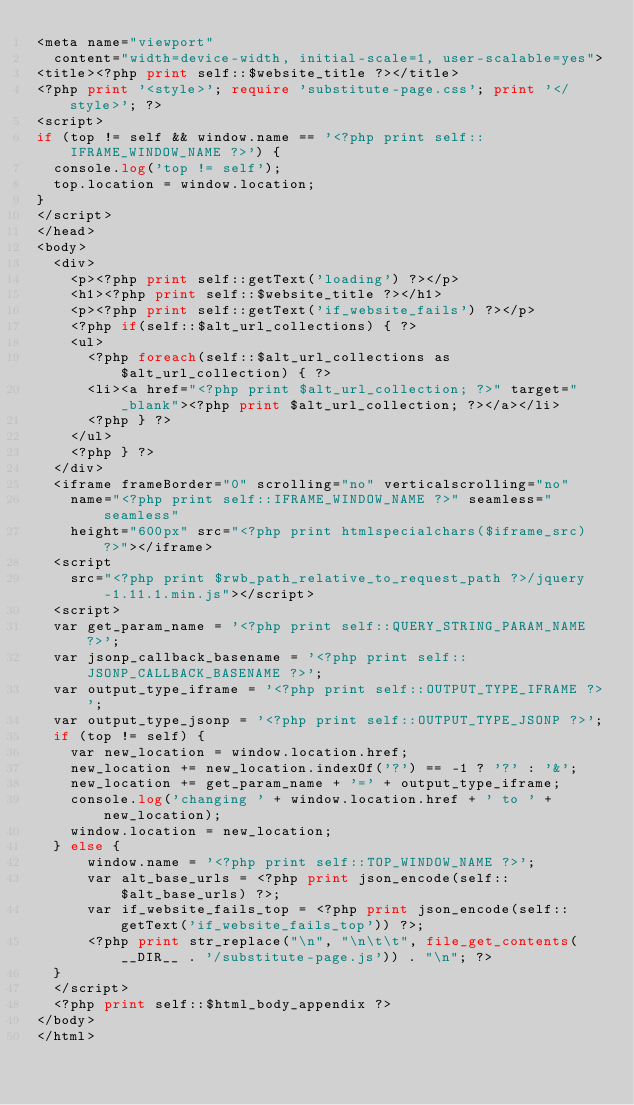<code> <loc_0><loc_0><loc_500><loc_500><_PHP_><meta name="viewport"
	content="width=device-width, initial-scale=1, user-scalable=yes">
<title><?php print self::$website_title ?></title>
<?php print '<style>'; require 'substitute-page.css'; print '</style>'; ?>
<script>
if (top != self && window.name == '<?php print self::IFRAME_WINDOW_NAME ?>') {
	console.log('top != self');
	top.location = window.location;
}
</script>
</head>
<body>
	<div>
		<p><?php print self::getText('loading') ?></p>
		<h1><?php print self::$website_title ?></h1>
		<p><?php print self::getText('if_website_fails') ?></p>
		<?php if(self::$alt_url_collections) { ?>
		<ul>
			<?php foreach(self::$alt_url_collections as $alt_url_collection) { ?>
			<li><a href="<?php print $alt_url_collection; ?>" target="_blank"><?php print $alt_url_collection; ?></a></li>
			<?php } ?>
		</ul>
		<?php } ?>
	</div>
	<iframe frameBorder="0" scrolling="no" verticalscrolling="no"
		name="<?php print self::IFRAME_WINDOW_NAME ?>" seamless="seamless"
		height="600px" src="<?php print htmlspecialchars($iframe_src) ?>"></iframe>
	<script
		src="<?php print $rwb_path_relative_to_request_path ?>/jquery-1.11.1.min.js"></script>
	<script>
	var get_param_name = '<?php print self::QUERY_STRING_PARAM_NAME ?>';
	var jsonp_callback_basename = '<?php print self::JSONP_CALLBACK_BASENAME ?>';
	var output_type_iframe = '<?php print self::OUTPUT_TYPE_IFRAME ?>';
	var output_type_jsonp = '<?php print self::OUTPUT_TYPE_JSONP ?>';
	if (top != self) {
		var new_location = window.location.href;
		new_location += new_location.indexOf('?') == -1 ? '?' : '&';
		new_location += get_param_name + '=' + output_type_iframe;
		console.log('changing ' + window.location.href + ' to ' + new_location);
		window.location = new_location;
	} else {
    	window.name = '<?php print self::TOP_WINDOW_NAME ?>';
    	var alt_base_urls = <?php print json_encode(self::$alt_base_urls) ?>;
    	var if_website_fails_top = <?php print json_encode(self::getText('if_website_fails_top')) ?>;
    	<?php print str_replace("\n", "\n\t\t", file_get_contents(__DIR__ . '/substitute-page.js')) . "\n"; ?>
	}
	</script>
	<?php print self::$html_body_appendix ?>
</body>
</html></code> 